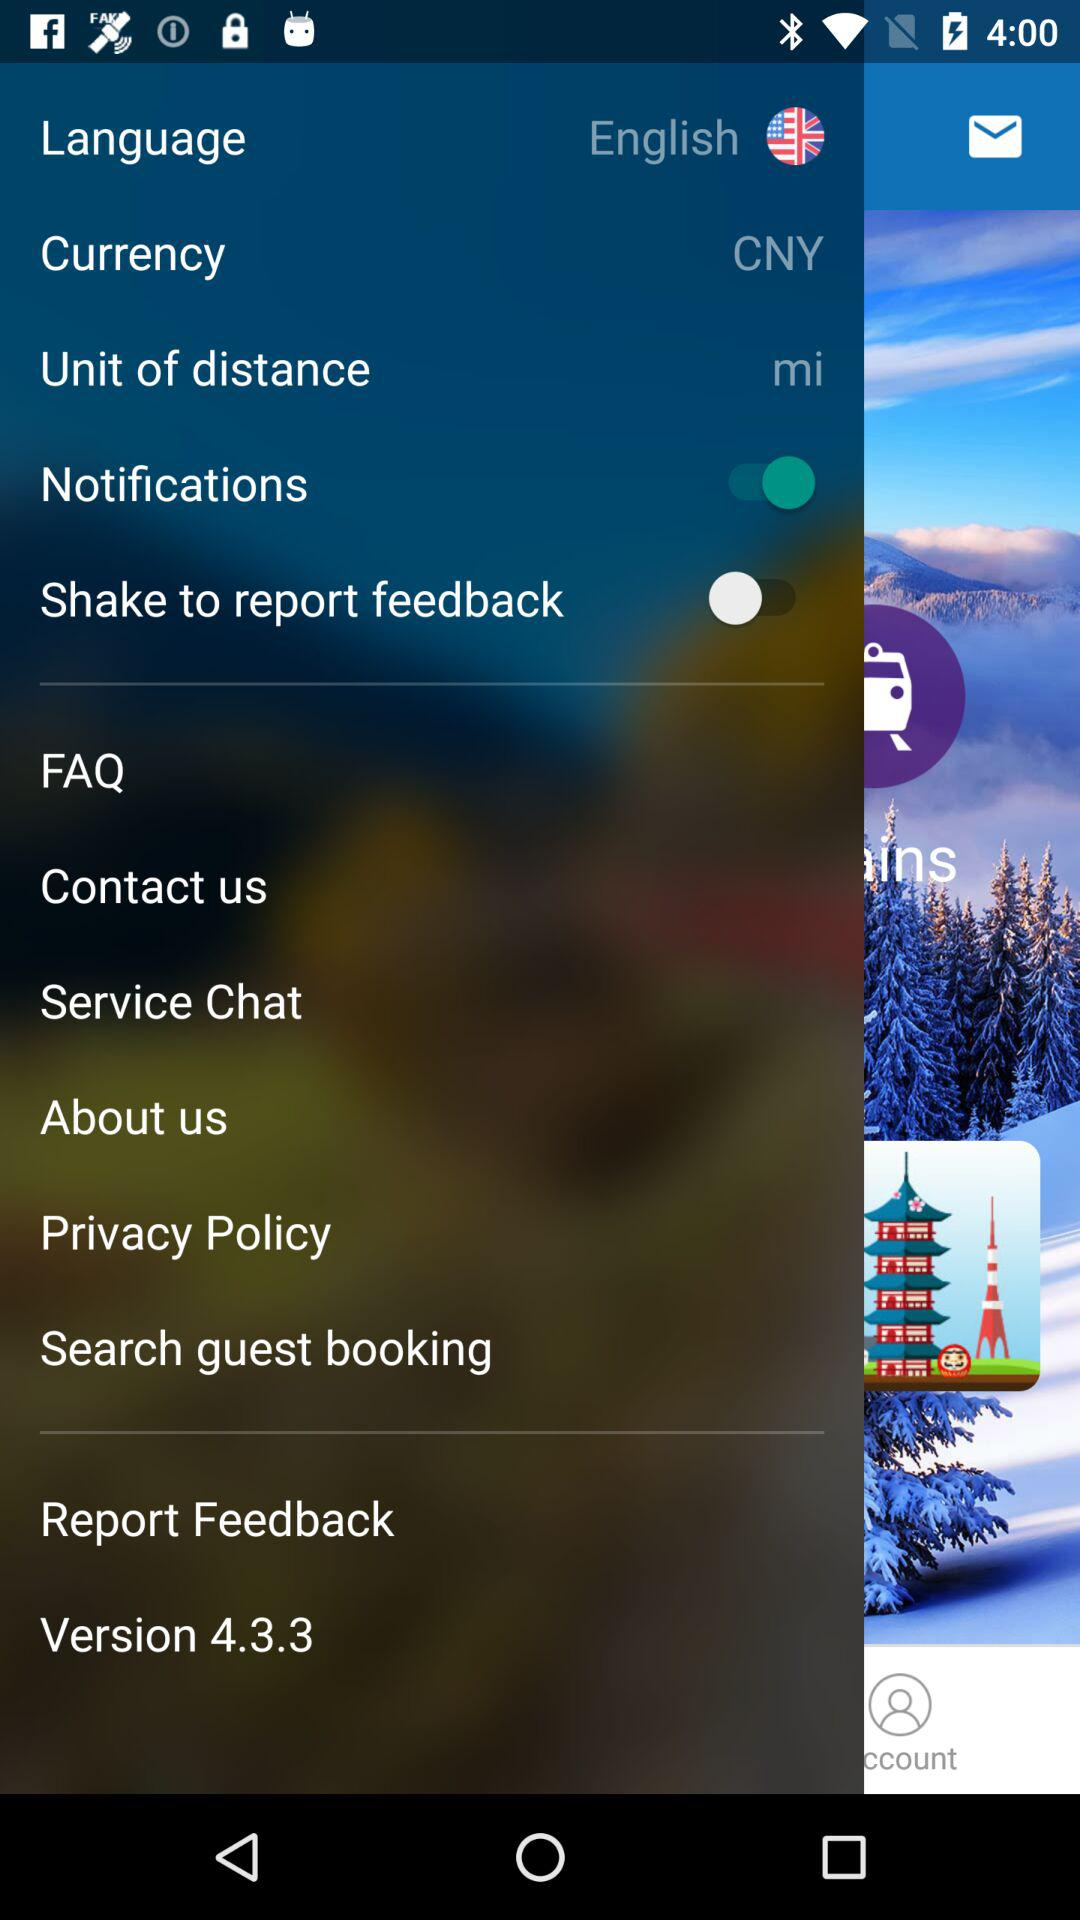What is the unit of distance? The unit of distance is miles. 